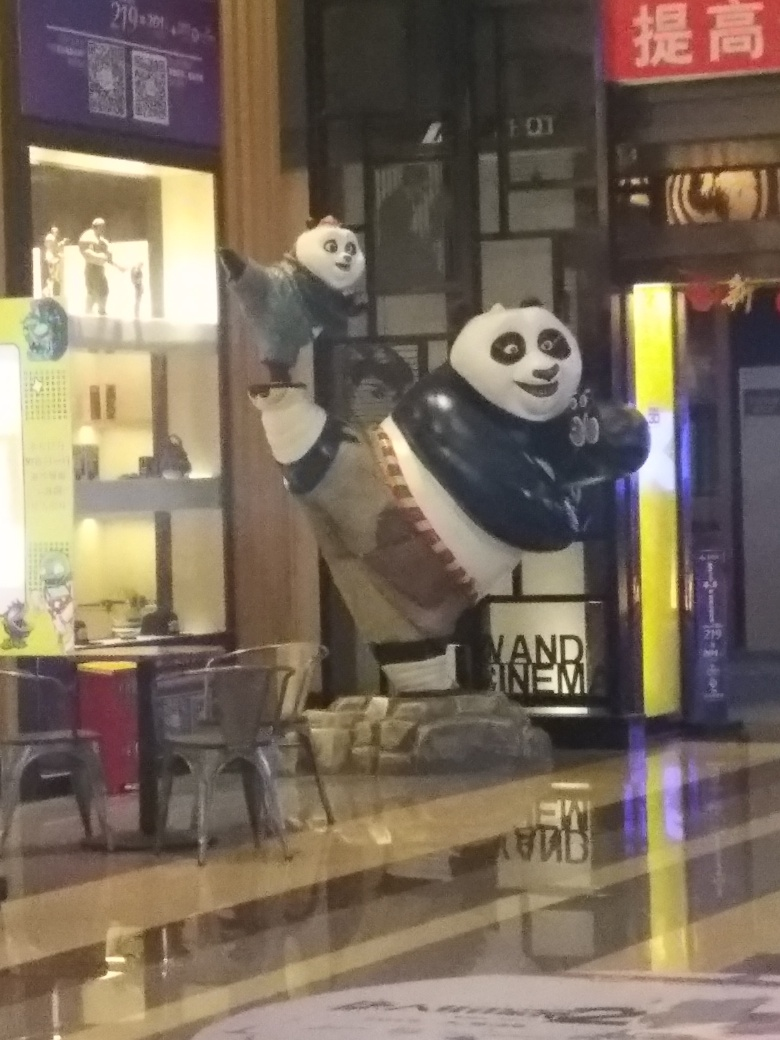Can you tell me more about the setting in which this panda figure is displayed? The image indicates an indoor setting with a shiny, reflective flooring that hints at a commercial or retail environment. The other elements, such as chairs, the counter, and the signage, reinforce the idea that this is a public space, intended for visitors to peruse or gather in. How does the lighting affect the atmosphere of the place? The lighting creates a vivid reflection on the floor, which adds depth and can be seen as adding an element of intrigue or ambience to the setting. However, the dimness might also make the area appear more tranquil and inviting, depending on the intentions of the space's designers. 